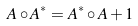Convert formula to latex. <formula><loc_0><loc_0><loc_500><loc_500>A \circ A ^ { \ast } = A ^ { \ast } \circ A + 1</formula> 